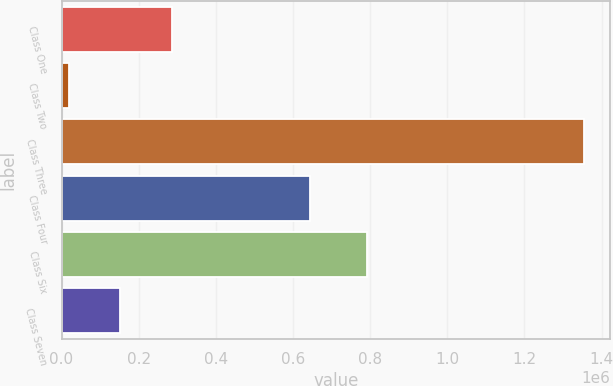Convert chart to OTSL. <chart><loc_0><loc_0><loc_500><loc_500><bar_chart><fcel>Class One<fcel>Class Two<fcel>Class Three<fcel>Class Four<fcel>Class Six<fcel>Class Seven<nl><fcel>285689<fcel>18589<fcel>1.35409e+06<fcel>644954<fcel>790883<fcel>152139<nl></chart> 